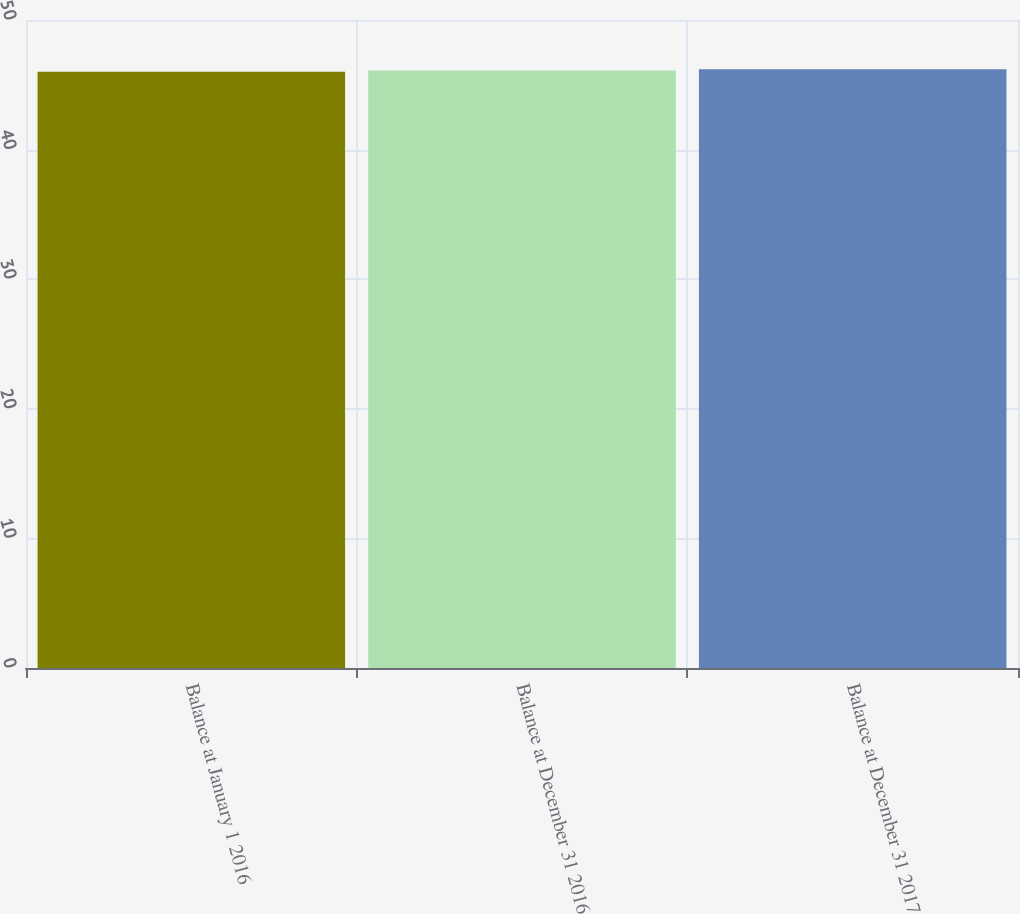Convert chart to OTSL. <chart><loc_0><loc_0><loc_500><loc_500><bar_chart><fcel>Balance at January 1 2016<fcel>Balance at December 31 2016<fcel>Balance at December 31 2017<nl><fcel>46<fcel>46.1<fcel>46.2<nl></chart> 